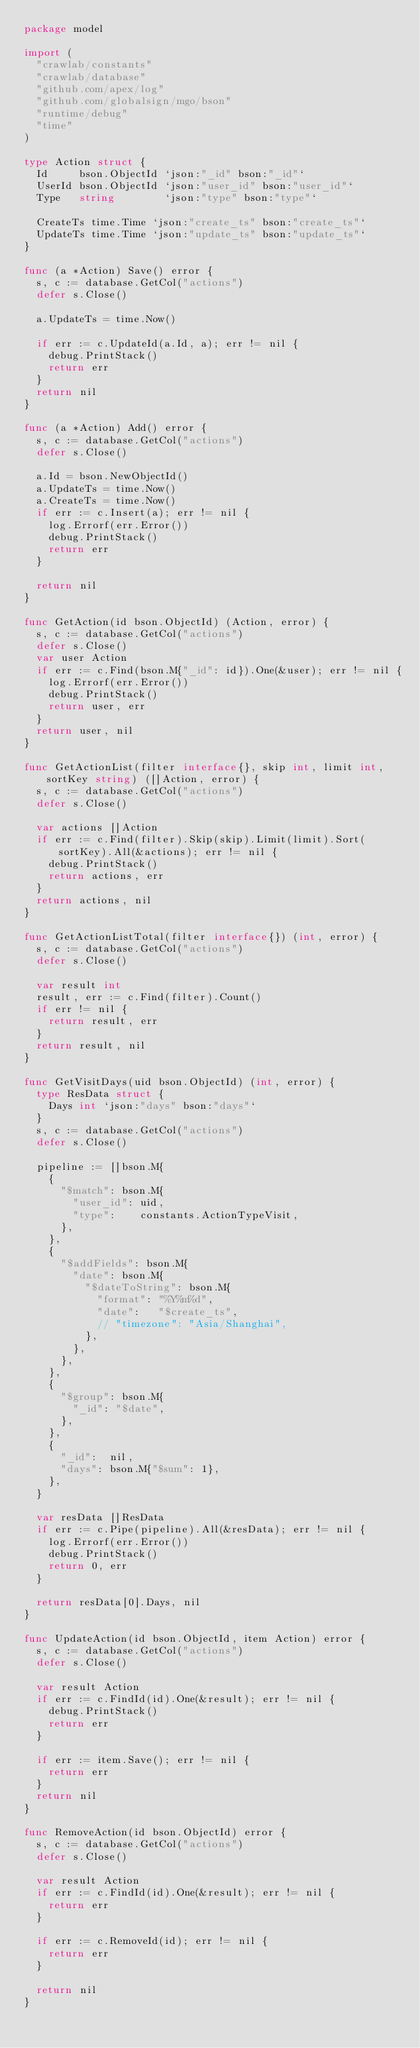Convert code to text. <code><loc_0><loc_0><loc_500><loc_500><_Go_>package model

import (
	"crawlab/constants"
	"crawlab/database"
	"github.com/apex/log"
	"github.com/globalsign/mgo/bson"
	"runtime/debug"
	"time"
)

type Action struct {
	Id     bson.ObjectId `json:"_id" bson:"_id"`
	UserId bson.ObjectId `json:"user_id" bson:"user_id"`
	Type   string        `json:"type" bson:"type"`

	CreateTs time.Time `json:"create_ts" bson:"create_ts"`
	UpdateTs time.Time `json:"update_ts" bson:"update_ts"`
}

func (a *Action) Save() error {
	s, c := database.GetCol("actions")
	defer s.Close()

	a.UpdateTs = time.Now()

	if err := c.UpdateId(a.Id, a); err != nil {
		debug.PrintStack()
		return err
	}
	return nil
}

func (a *Action) Add() error {
	s, c := database.GetCol("actions")
	defer s.Close()

	a.Id = bson.NewObjectId()
	a.UpdateTs = time.Now()
	a.CreateTs = time.Now()
	if err := c.Insert(a); err != nil {
		log.Errorf(err.Error())
		debug.PrintStack()
		return err
	}

	return nil
}

func GetAction(id bson.ObjectId) (Action, error) {
	s, c := database.GetCol("actions")
	defer s.Close()
	var user Action
	if err := c.Find(bson.M{"_id": id}).One(&user); err != nil {
		log.Errorf(err.Error())
		debug.PrintStack()
		return user, err
	}
	return user, nil
}

func GetActionList(filter interface{}, skip int, limit int, sortKey string) ([]Action, error) {
	s, c := database.GetCol("actions")
	defer s.Close()

	var actions []Action
	if err := c.Find(filter).Skip(skip).Limit(limit).Sort(sortKey).All(&actions); err != nil {
		debug.PrintStack()
		return actions, err
	}
	return actions, nil
}

func GetActionListTotal(filter interface{}) (int, error) {
	s, c := database.GetCol("actions")
	defer s.Close()

	var result int
	result, err := c.Find(filter).Count()
	if err != nil {
		return result, err
	}
	return result, nil
}

func GetVisitDays(uid bson.ObjectId) (int, error) {
	type ResData struct {
		Days int `json:"days" bson:"days"`
	}
	s, c := database.GetCol("actions")
	defer s.Close()

	pipeline := []bson.M{
		{
			"$match": bson.M{
				"user_id": uid,
				"type":    constants.ActionTypeVisit,
			},
		},
		{
			"$addFields": bson.M{
				"date": bson.M{
					"$dateToString": bson.M{
						"format": "%Y%m%d",
						"date":   "$create_ts",
						// "timezone": "Asia/Shanghai",
					},
				},
			},
		},
		{
			"$group": bson.M{
				"_id": "$date",
			},
		},
		{
			"_id":  nil,
			"days": bson.M{"$sum": 1},
		},
	}

	var resData []ResData
	if err := c.Pipe(pipeline).All(&resData); err != nil {
		log.Errorf(err.Error())
		debug.PrintStack()
		return 0, err
	}

	return resData[0].Days, nil
}

func UpdateAction(id bson.ObjectId, item Action) error {
	s, c := database.GetCol("actions")
	defer s.Close()

	var result Action
	if err := c.FindId(id).One(&result); err != nil {
		debug.PrintStack()
		return err
	}

	if err := item.Save(); err != nil {
		return err
	}
	return nil
}

func RemoveAction(id bson.ObjectId) error {
	s, c := database.GetCol("actions")
	defer s.Close()

	var result Action
	if err := c.FindId(id).One(&result); err != nil {
		return err
	}

	if err := c.RemoveId(id); err != nil {
		return err
	}

	return nil
}
</code> 